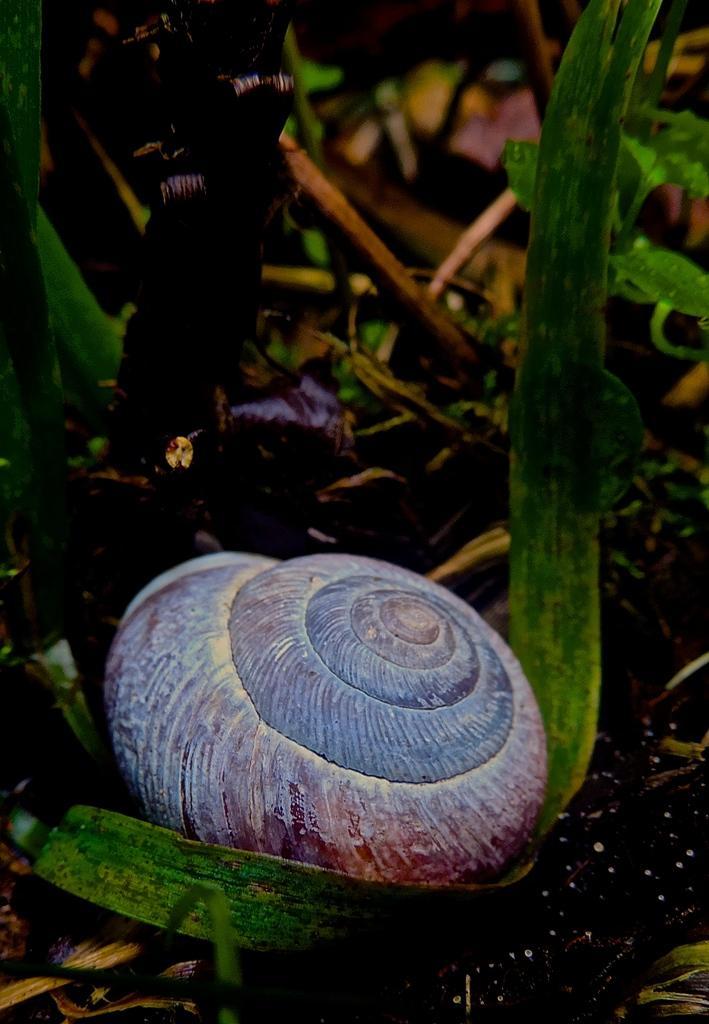How would you summarize this image in a sentence or two? In this image I can see the shell. To the side of the shell I can see the sticks and plants. 